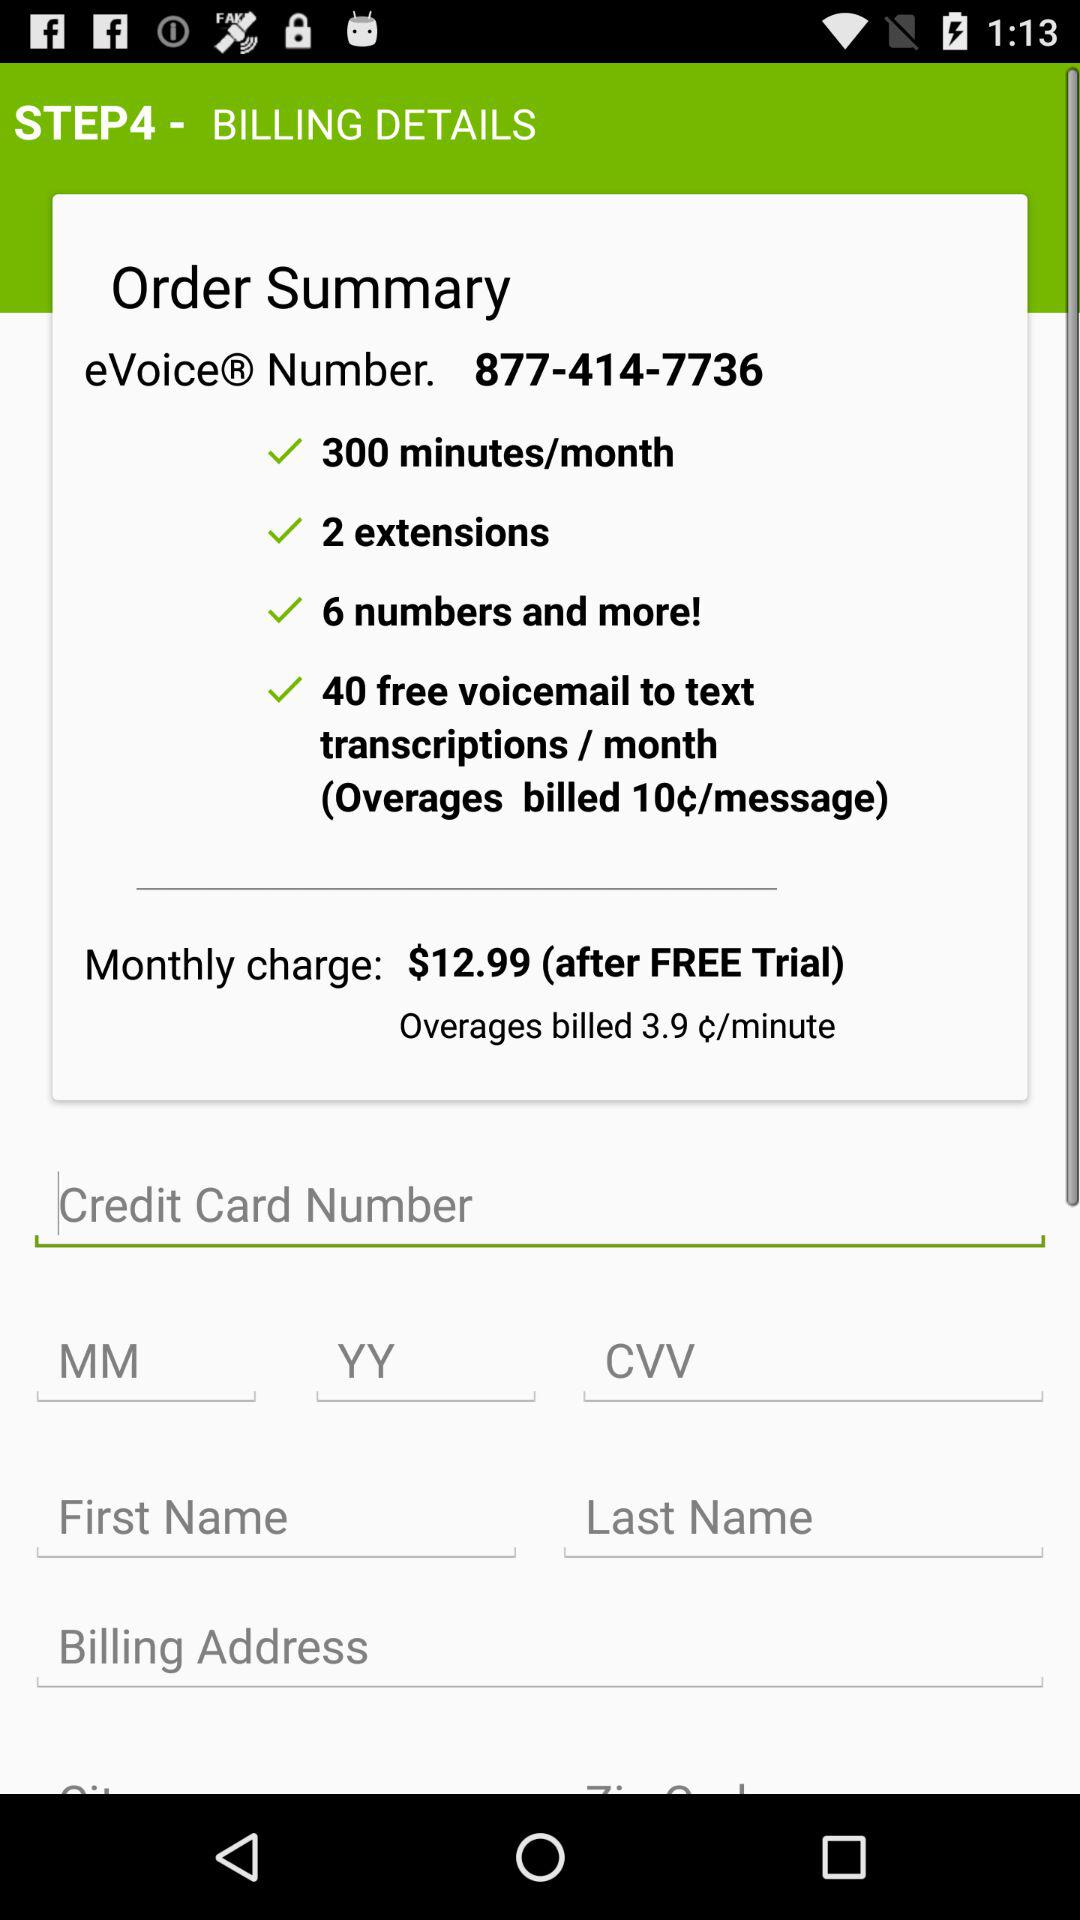What is the eVoice number? The eVoice number is 877-414-7736. 